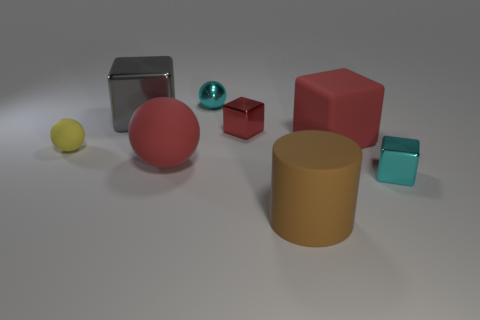How many objects are matte spheres left of the big metallic object or large rubber cubes behind the cyan cube?
Ensure brevity in your answer.  2. What is the material of the small red thing on the right side of the cyan object behind the large gray cube?
Provide a short and direct response. Metal. Does the gray thing have the same shape as the small yellow thing?
Make the answer very short. No. What size is the brown object in front of the red ball?
Offer a terse response. Large. Does the brown cylinder have the same size as the cyan thing to the right of the large brown matte cylinder?
Provide a succinct answer. No. Are there fewer tiny cyan metal things that are in front of the large gray cube than big blocks?
Keep it short and to the point. Yes. What is the material of the cyan thing that is the same shape as the gray shiny thing?
Provide a short and direct response. Metal. There is a thing that is on the left side of the tiny red shiny cube and in front of the yellow matte object; what shape is it?
Offer a very short reply. Sphere. There is a tiny yellow thing that is made of the same material as the brown object; what is its shape?
Make the answer very short. Sphere. There is a tiny sphere that is behind the big red block; what is it made of?
Offer a very short reply. Metal. 